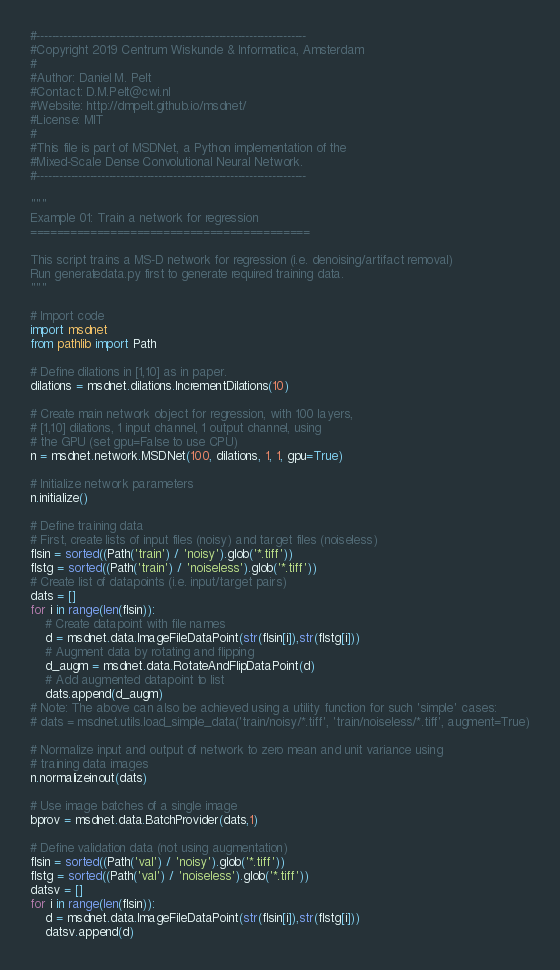Convert code to text. <code><loc_0><loc_0><loc_500><loc_500><_Python_>#-----------------------------------------------------------------------
#Copyright 2019 Centrum Wiskunde & Informatica, Amsterdam
#
#Author: Daniel M. Pelt
#Contact: D.M.Pelt@cwi.nl
#Website: http://dmpelt.github.io/msdnet/
#License: MIT
#
#This file is part of MSDNet, a Python implementation of the
#Mixed-Scale Dense Convolutional Neural Network.
#-----------------------------------------------------------------------

"""
Example 01: Train a network for regression
==========================================

This script trains a MS-D network for regression (i.e. denoising/artifact removal)
Run generatedata.py first to generate required training data.
"""

# Import code
import msdnet
from pathlib import Path

# Define dilations in [1,10] as in paper.
dilations = msdnet.dilations.IncrementDilations(10)

# Create main network object for regression, with 100 layers,
# [1,10] dilations, 1 input channel, 1 output channel, using
# the GPU (set gpu=False to use CPU)
n = msdnet.network.MSDNet(100, dilations, 1, 1, gpu=True)

# Initialize network parameters
n.initialize()

# Define training data
# First, create lists of input files (noisy) and target files (noiseless)
flsin = sorted((Path('train') / 'noisy').glob('*.tiff'))
flstg = sorted((Path('train') / 'noiseless').glob('*.tiff'))
# Create list of datapoints (i.e. input/target pairs)
dats = []
for i in range(len(flsin)):
    # Create datapoint with file names
    d = msdnet.data.ImageFileDataPoint(str(flsin[i]),str(flstg[i]))
    # Augment data by rotating and flipping
    d_augm = msdnet.data.RotateAndFlipDataPoint(d)
    # Add augmented datapoint to list
    dats.append(d_augm)
# Note: The above can also be achieved using a utility function for such 'simple' cases:
# dats = msdnet.utils.load_simple_data('train/noisy/*.tiff', 'train/noiseless/*.tiff', augment=True)

# Normalize input and output of network to zero mean and unit variance using
# training data images
n.normalizeinout(dats)

# Use image batches of a single image
bprov = msdnet.data.BatchProvider(dats,1)

# Define validation data (not using augmentation)
flsin = sorted((Path('val') / 'noisy').glob('*.tiff'))
flstg = sorted((Path('val') / 'noiseless').glob('*.tiff'))
datsv = []
for i in range(len(flsin)):
    d = msdnet.data.ImageFileDataPoint(str(flsin[i]),str(flstg[i]))
    datsv.append(d)</code> 